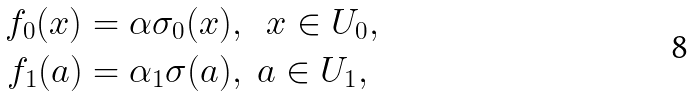<formula> <loc_0><loc_0><loc_500><loc_500>f _ { 0 } ( x ) & = \alpha \sigma _ { 0 } ( x ) , \ \ x \in U _ { 0 } , \\ f _ { 1 } ( a ) & = \alpha _ { 1 } \sigma ( a ) , \ a \in U _ { 1 } ,</formula> 